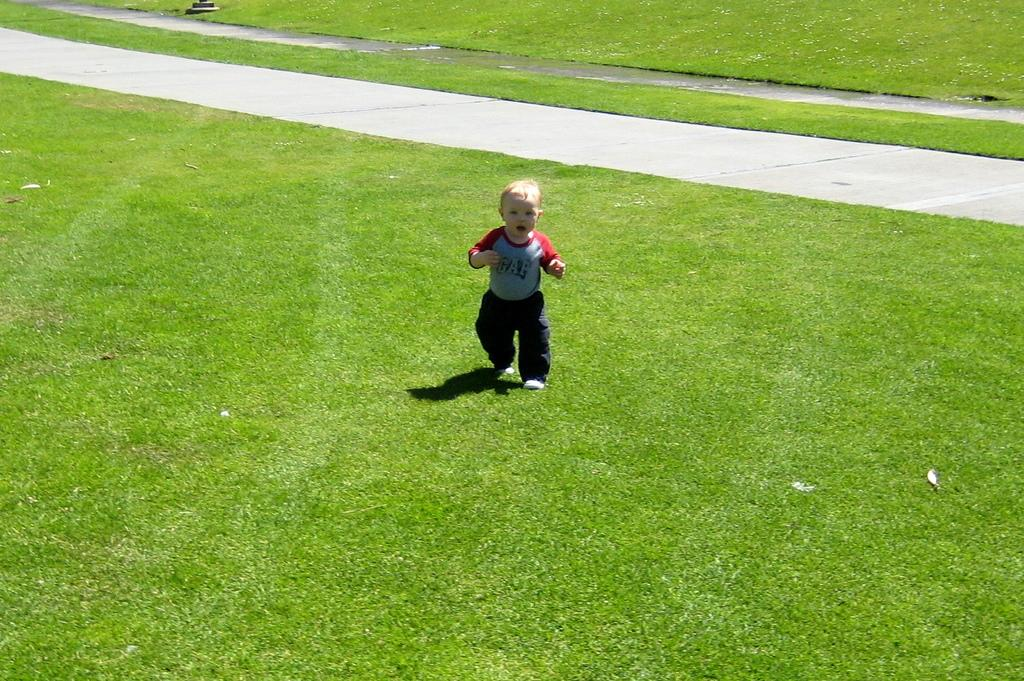What is the main subject of the image? There is a child in the image. Where is the child located? The child is on the grass. What is the child wearing? The child is wearing a dress with blue, red, and black colors. What else can be seen in the image? There is a road visible in the image. Can you see any boats in the harbor in the image? There is no harbor or boats present in the image. What type of guitar is the child playing in the image? There is no guitar present in the image. 